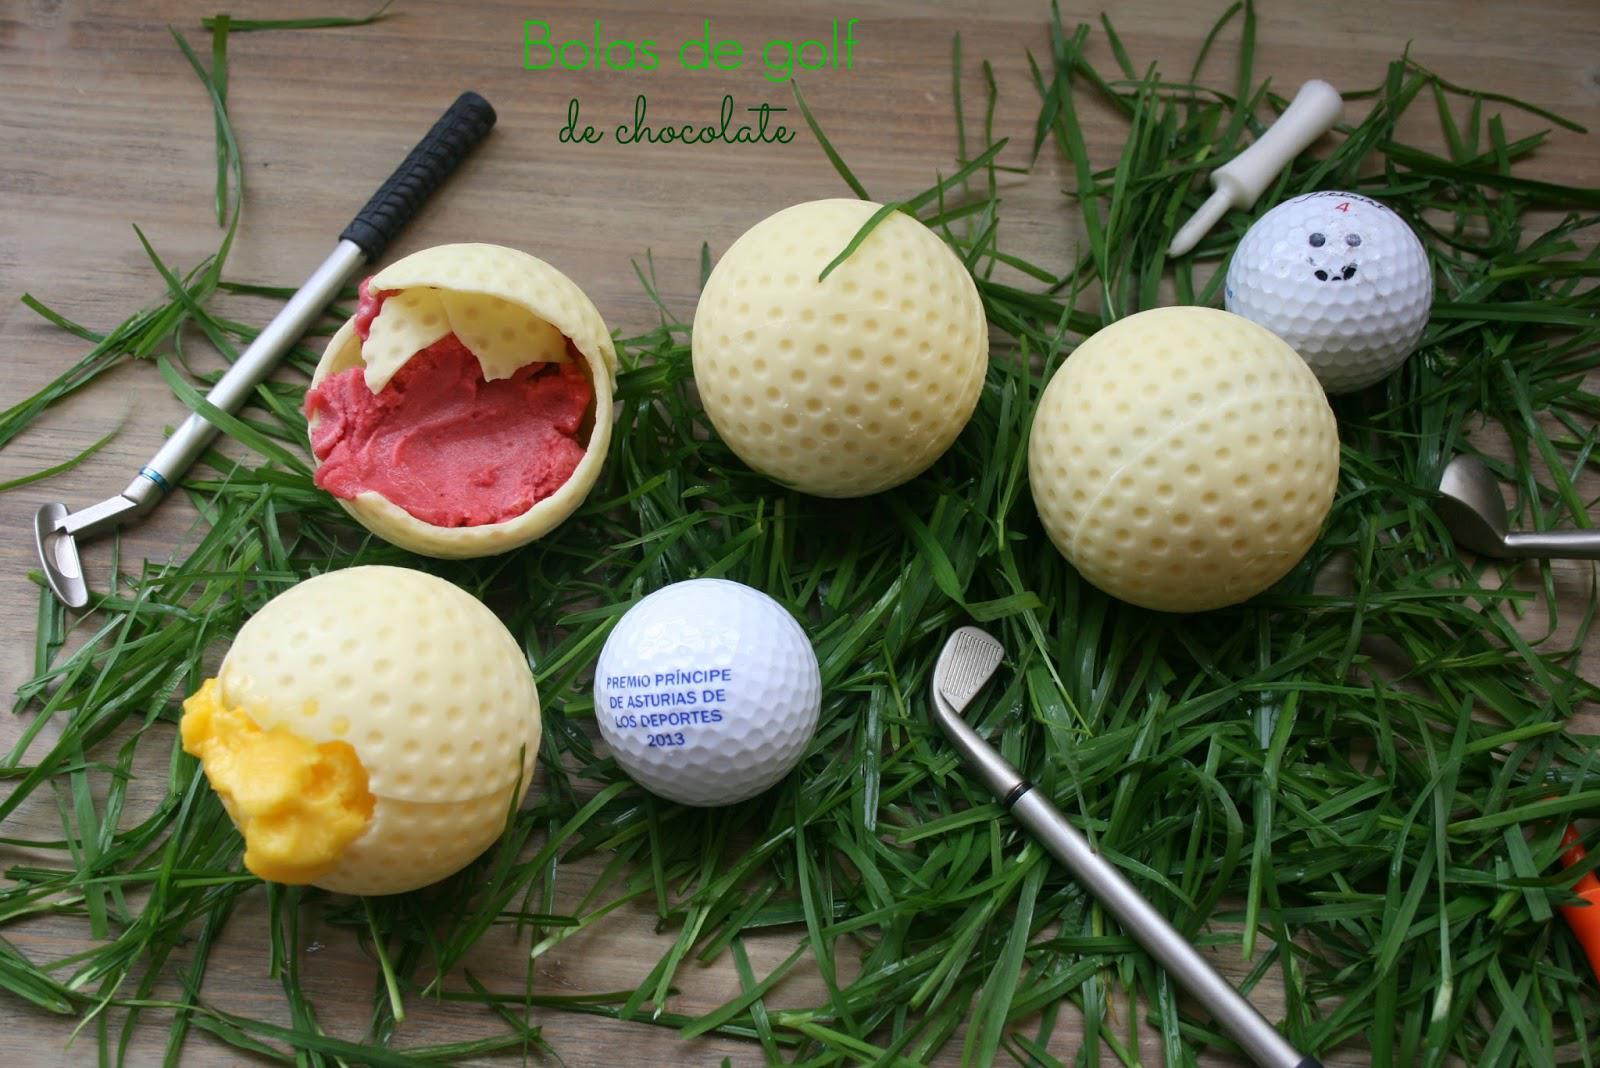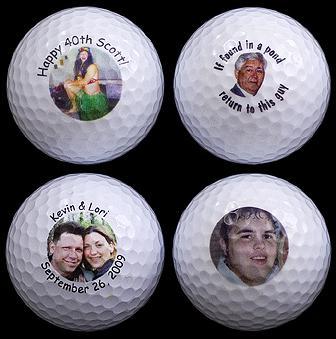The first image is the image on the left, the second image is the image on the right. Considering the images on both sides, is "There is an open ball with something inside it in the left image, but not in the right." valid? Answer yes or no. Yes. 